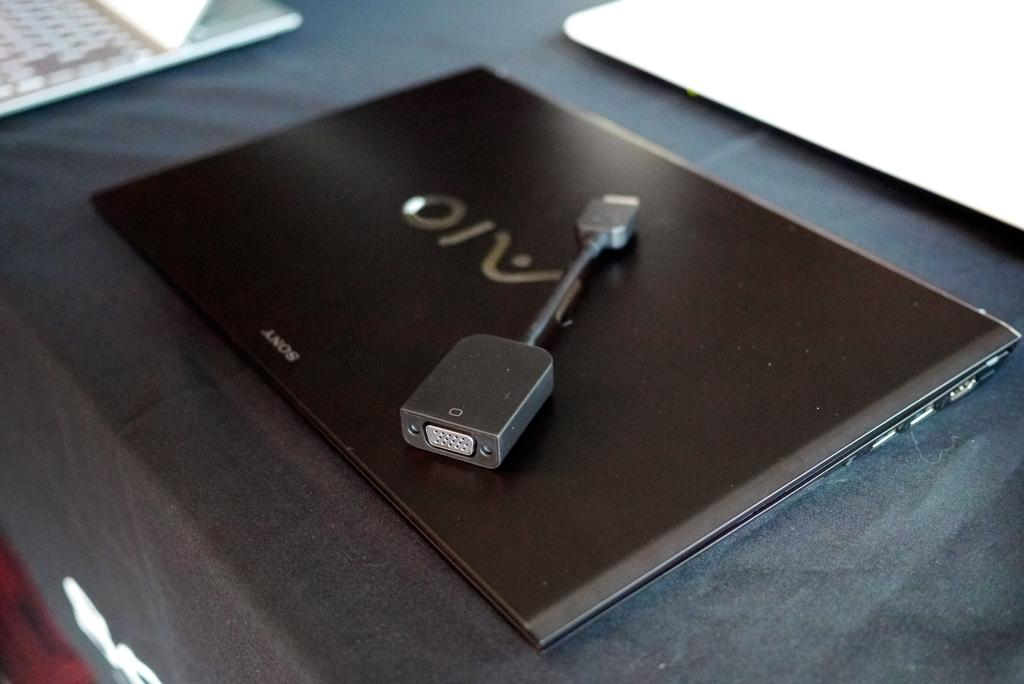What electronic device is visible in the image? There is a laptop in the image. Where is the laptop located? The laptop is placed on a table. What can be seen on the table besides the laptop? There is a plug placed on the table. How does the laptop provide comfort to the cattle in the image? There are no cattle present in the image, and the laptop is not providing comfort to any animals. 